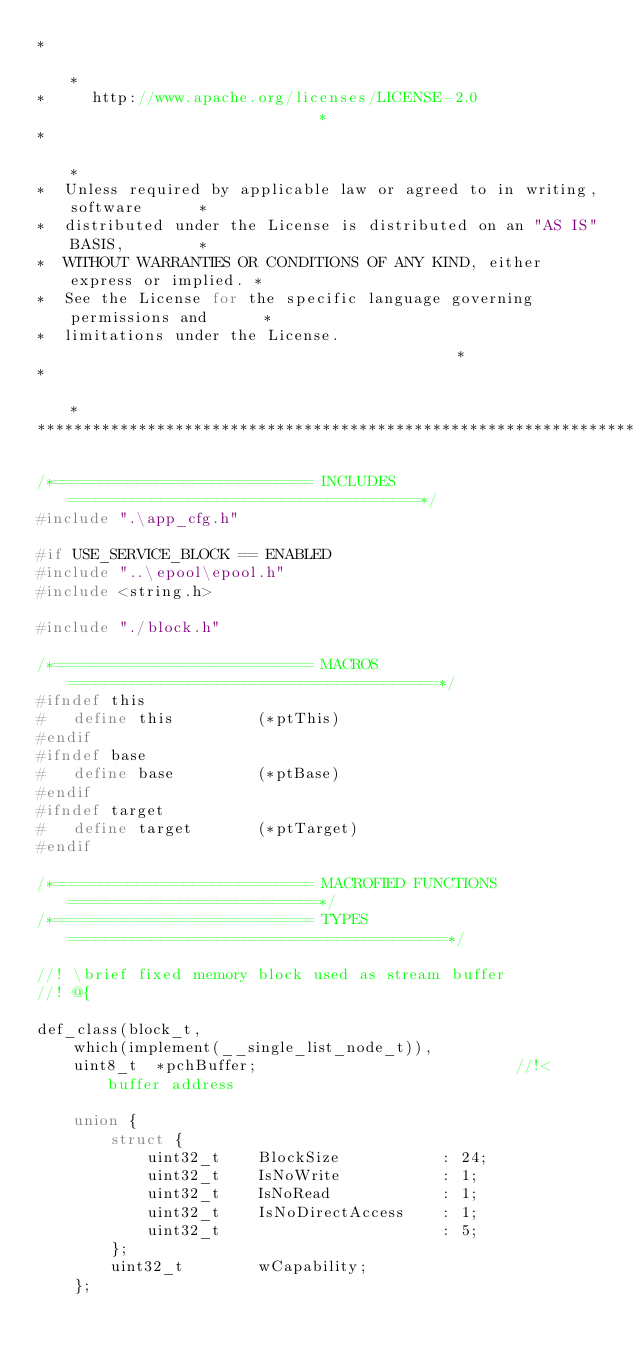<code> <loc_0><loc_0><loc_500><loc_500><_C_>*                                                                           *
*     http://www.apache.org/licenses/LICENSE-2.0                            *
*                                                                           *
*  Unless required by applicable law or agreed to in writing, software      *
*  distributed under the License is distributed on an "AS IS" BASIS,        *
*  WITHOUT WARRANTIES OR CONDITIONS OF ANY KIND, either express or implied. *
*  See the License for the specific language governing permissions and      *
*  limitations under the License.                                           *
*                                                                           *
****************************************************************************/

/*============================ INCLUDES ======================================*/
#include ".\app_cfg.h"

#if USE_SERVICE_BLOCK == ENABLED
#include "..\epool\epool.h"
#include <string.h>

#include "./block.h"

/*============================ MACROS ========================================*/
#ifndef this
#   define this         (*ptThis)
#endif
#ifndef base
#   define base         (*ptBase)
#endif
#ifndef target
#   define target       (*ptTarget)
#endif

/*============================ MACROFIED FUNCTIONS ===========================*/
/*============================ TYPES =========================================*/

//! \brief fixed memory block used as stream buffer
//! @{

def_class(block_t,
    which(implement(__single_list_node_t)),
    uint8_t  *pchBuffer;                            //!< buffer address

    union {
        struct {
            uint32_t    BlockSize           : 24;
            uint32_t    IsNoWrite           : 1;
            uint32_t    IsNoRead            : 1;
            uint32_t    IsNoDirectAccess    : 1;
            uint32_t                        : 5;
        };
        uint32_t        wCapability;
    };
</code> 